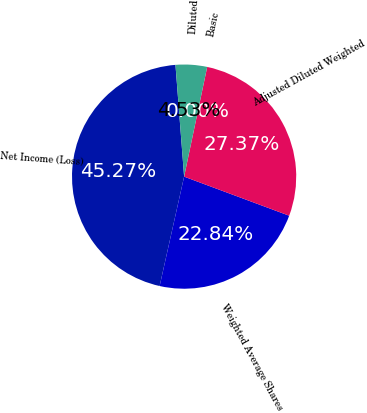Convert chart to OTSL. <chart><loc_0><loc_0><loc_500><loc_500><pie_chart><fcel>Net Income (Loss)<fcel>Weighted Average Shares<fcel>Adjusted Diluted Weighted<fcel>Basic<fcel>Diluted<nl><fcel>45.27%<fcel>22.84%<fcel>27.37%<fcel>0.0%<fcel>4.53%<nl></chart> 